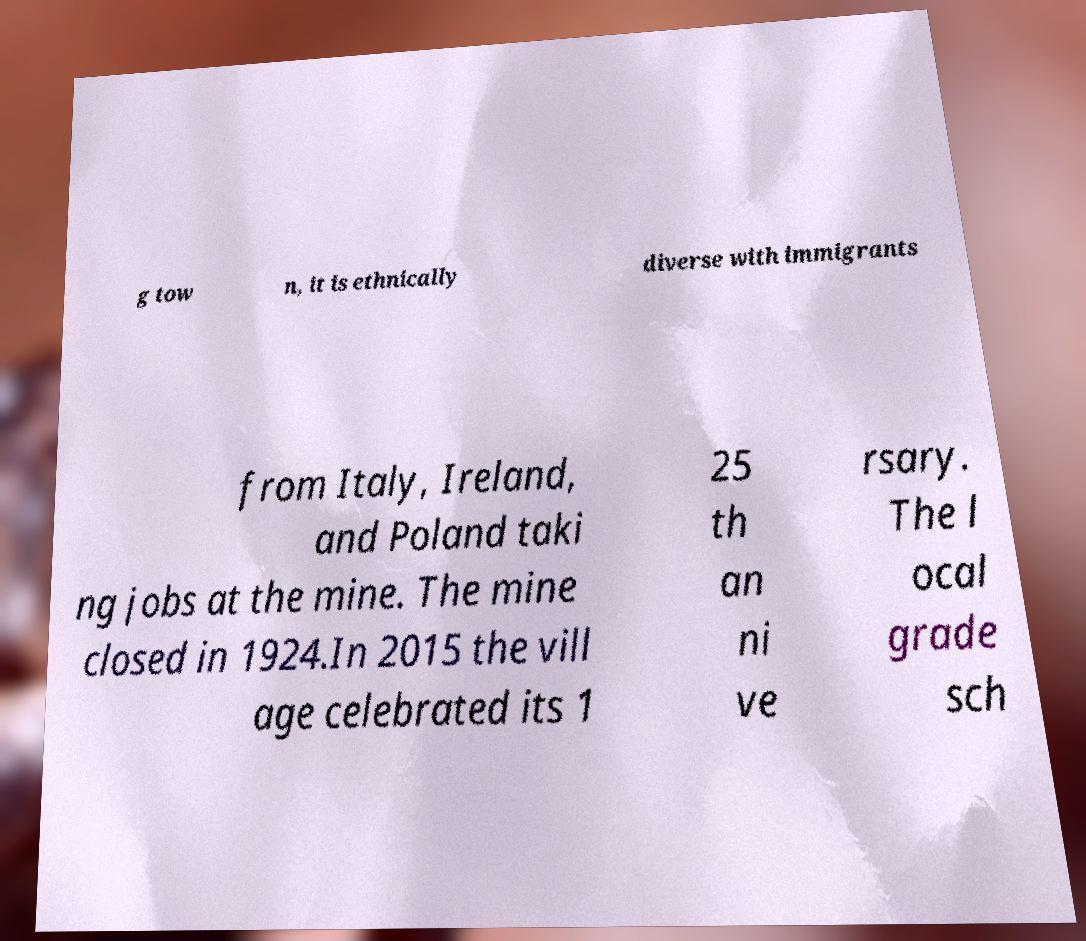I need the written content from this picture converted into text. Can you do that? g tow n, it is ethnically diverse with immigrants from Italy, Ireland, and Poland taki ng jobs at the mine. The mine closed in 1924.In 2015 the vill age celebrated its 1 25 th an ni ve rsary. The l ocal grade sch 